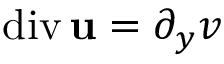<formula> <loc_0><loc_0><loc_500><loc_500>d i v \, { u } = \partial _ { y } v</formula> 